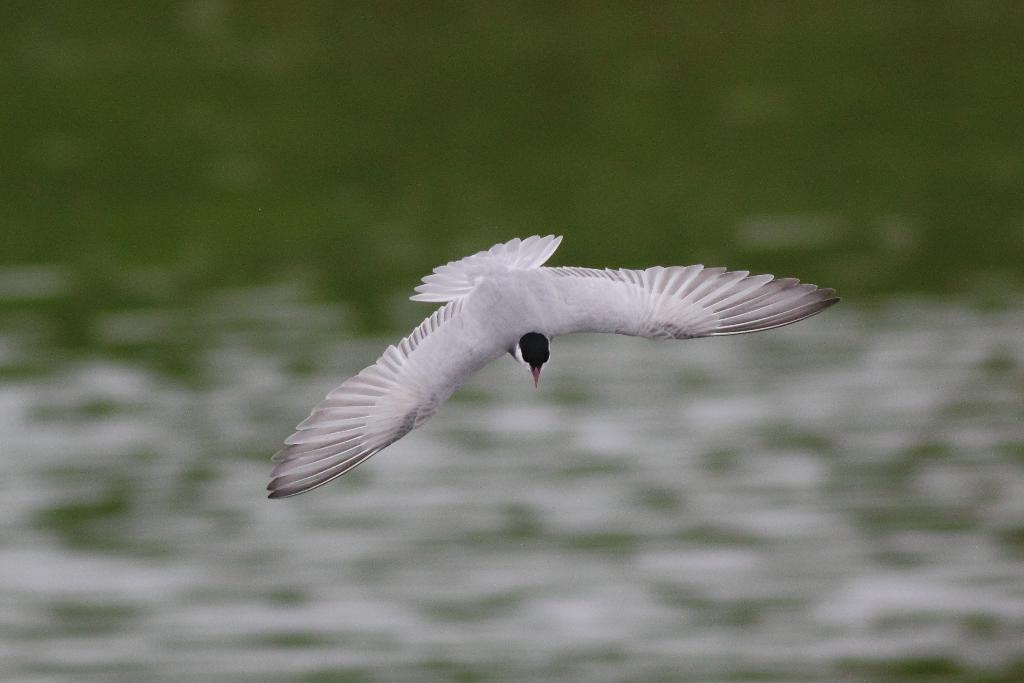What type of animal can be seen in the image? There is a bird in the image. What is the bird doing in the image? The bird is flying. What color is the bird in the image? The bird is white in color. What can be seen at the bottom of the image? There is water visible at the bottom of the image. How many rings does the bird have on its legs in the image? There are no rings visible on the bird's legs in the image. What type of river can be seen in the image? There is no river present in the image; it only features a bird flying over water. 